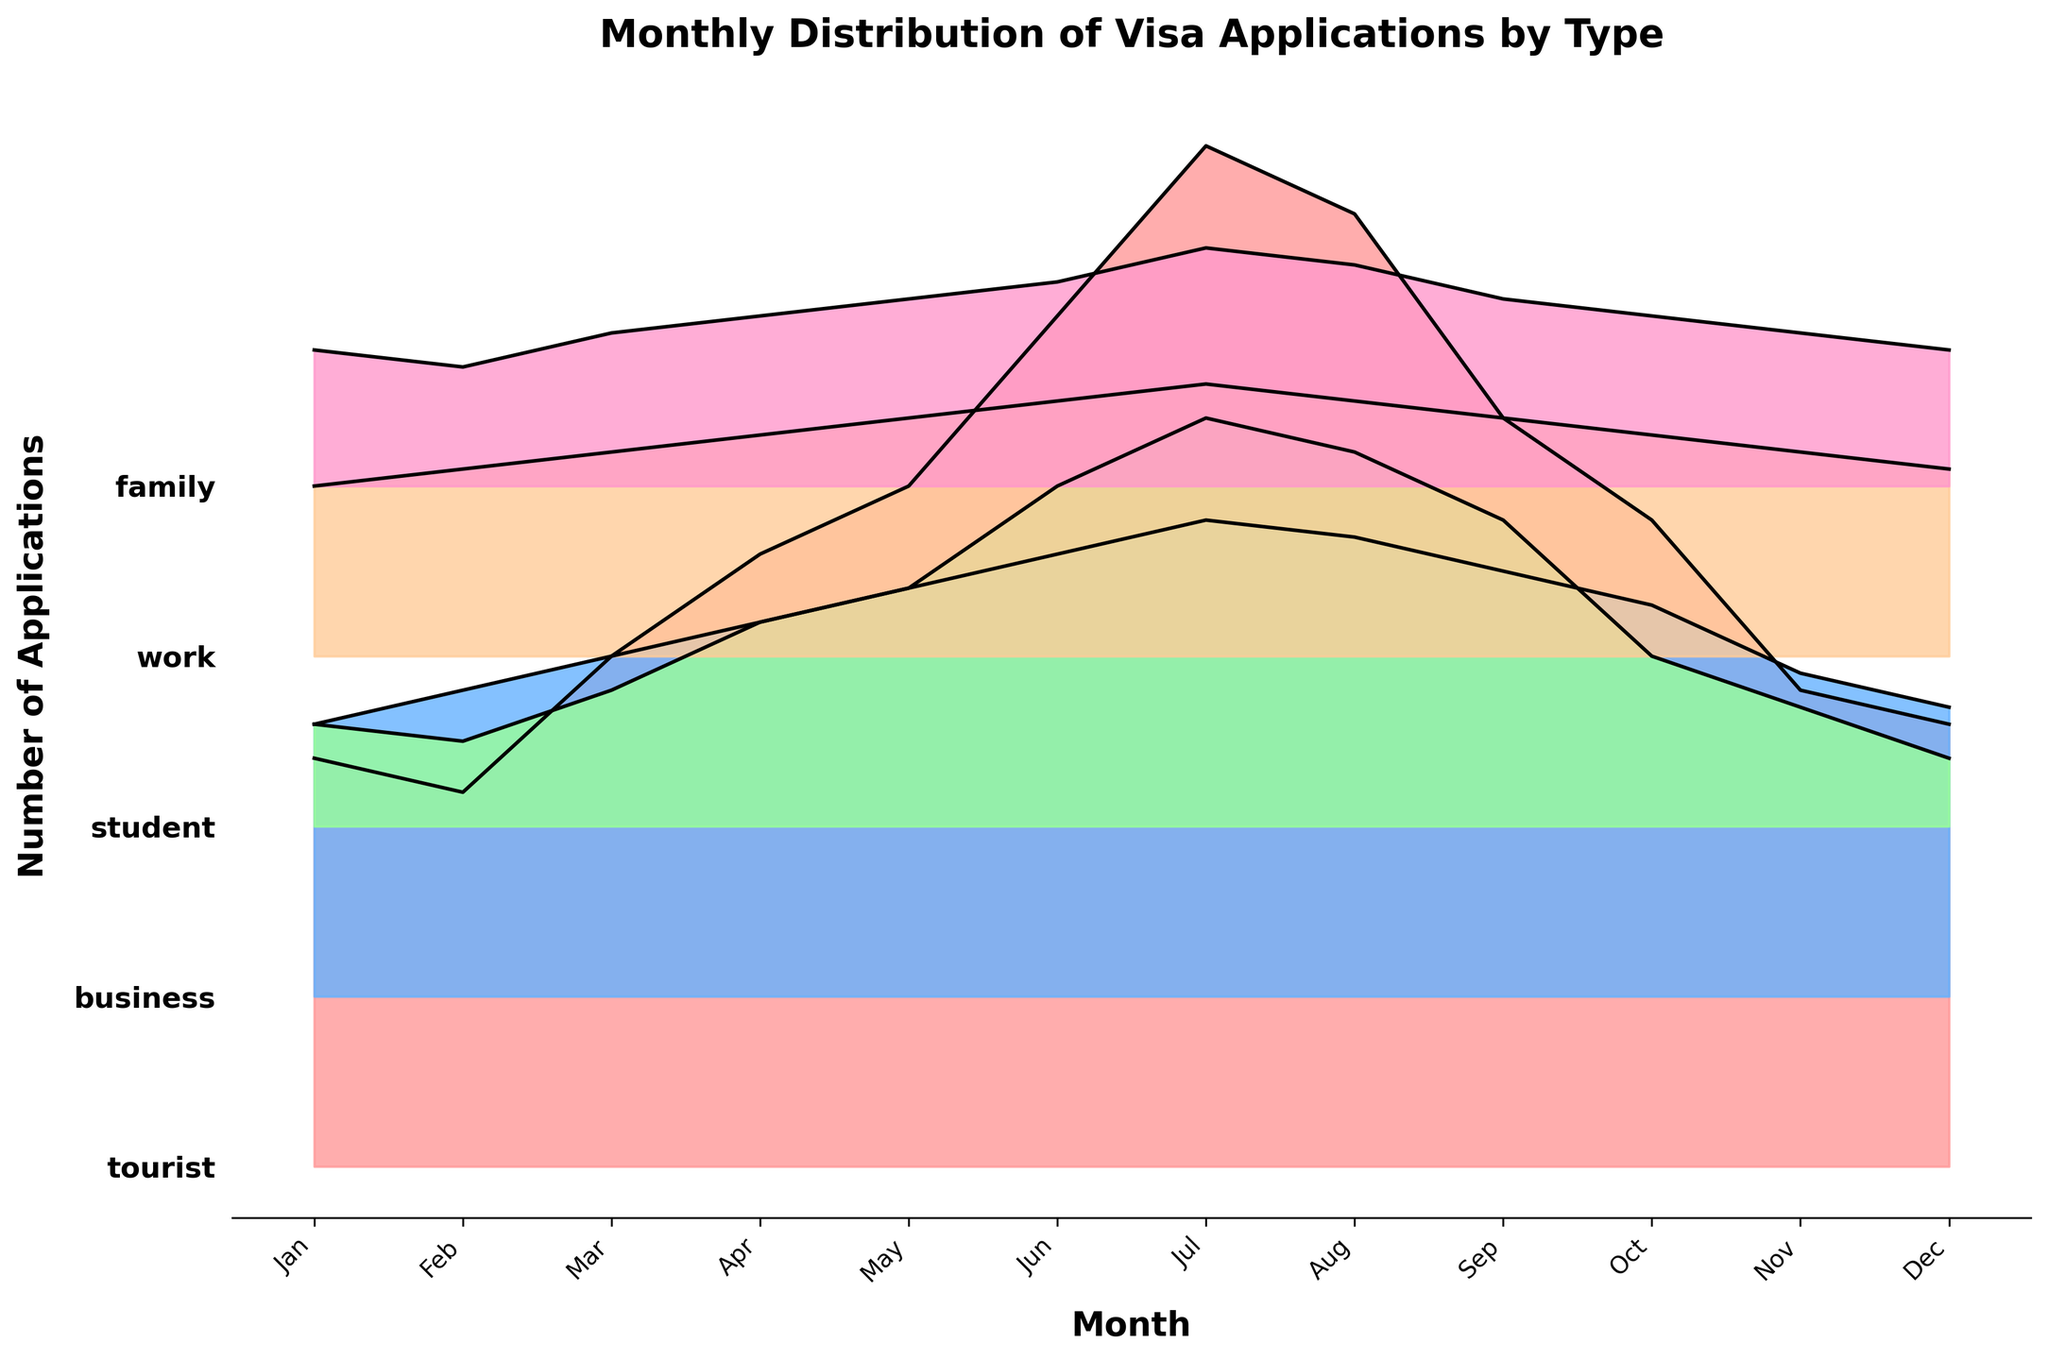What is the title of the plot? The title of the plot is displayed at the top and it should summarize the content of the figure.
Answer: Monthly Distribution of Visa Applications by Type Which visa type has the highest number of applications in July? Look at the ridgeline plot for July and identify which curve peaks the highest.
Answer: Tourist How many months are displayed in the figure? Count the number of tick marks on the x-axis, each representing one month.
Answer: 12 In which month do student visa applications peak? Find the highest point of the curve corresponding to student visas and note the month on the x-axis.
Answer: July Compare the number of tourist and business visa applications in December. Which type had more applications? Compare the height of the tourist and business visa curves for December.
Answer: Tourist Which visa type shows the smallest fluctuation in applications throughout the year? Analyze the curves and identify the one with the least variation in height across all months.
Answer: Family By approximately how many applications do work visas increase from February to June? Find the work visa application numbers for February and June, and calculate the difference between them.
Answer: 75 Which month shows the highest overall number of visa applications across all types? Sum the heights of all visa type curves for each month and identify the month with the highest sum.
Answer: July Are there any months where tourist visa applications are lower than business visa applications? Compare the curves of tourist and business visas month by month to identify such occurrences.
Answer: No What trend do you observe for student visa applications from January to June? Observe the curve for student visas from January to June to note the general direction (increasing or decreasing).
Answer: Increasing 